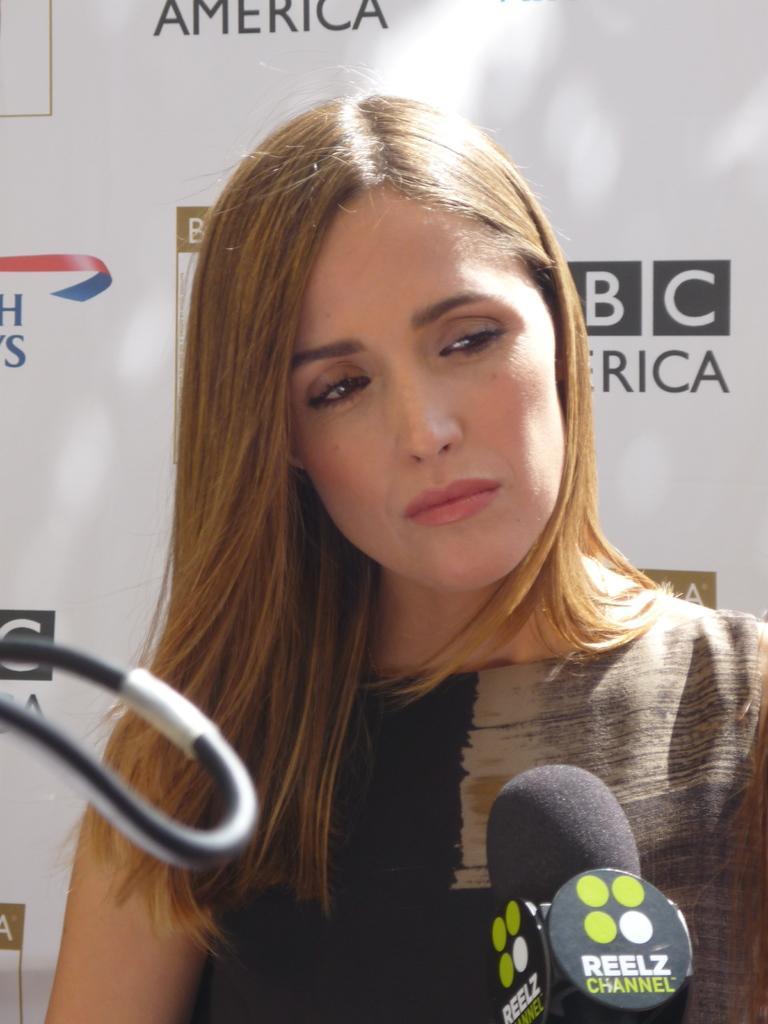Can you describe this image briefly? In this picture there is a girl in the center of the image, by holding a mic in her hand and there is a wire on the left side of the image, there is a flex in the background area of the image. 